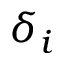<formula> <loc_0><loc_0><loc_500><loc_500>\delta _ { i }</formula> 